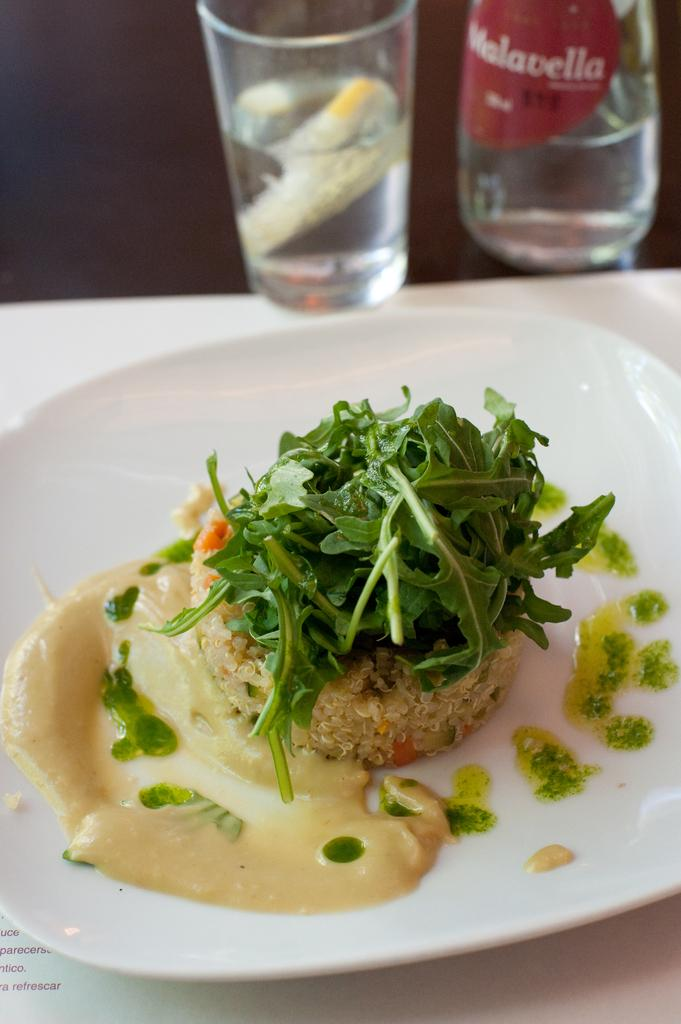<image>
Summarize the visual content of the image. A bottle of Melavella water next to a glass of water and a plate with food. 